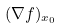Convert formula to latex. <formula><loc_0><loc_0><loc_500><loc_500>( \nabla f ) _ { x _ { 0 } }</formula> 